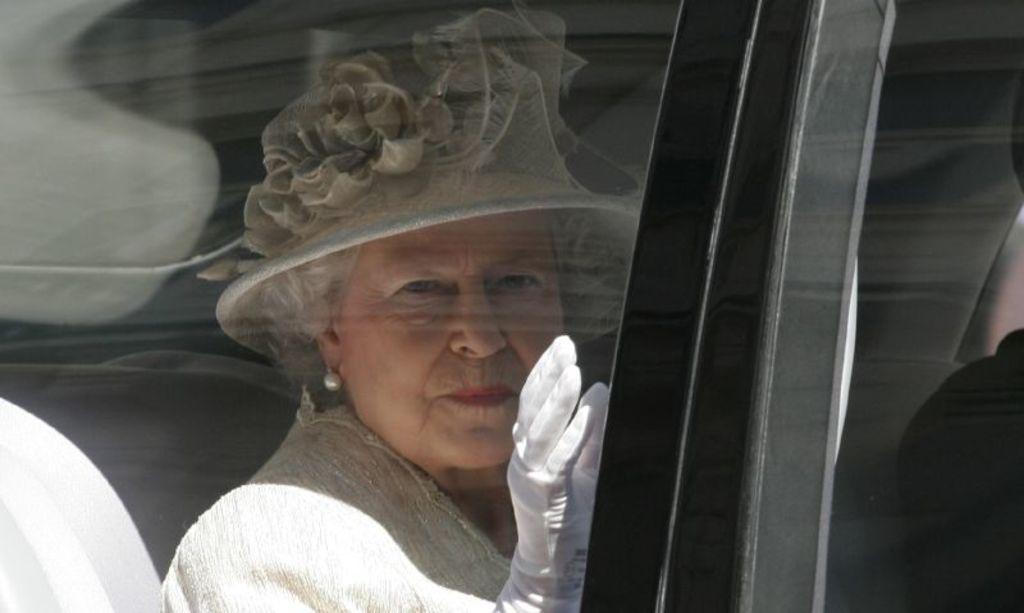Please provide a concise description of this image. In this image we can see few people sitting in a vehicle. A lady is wearing a hat. 